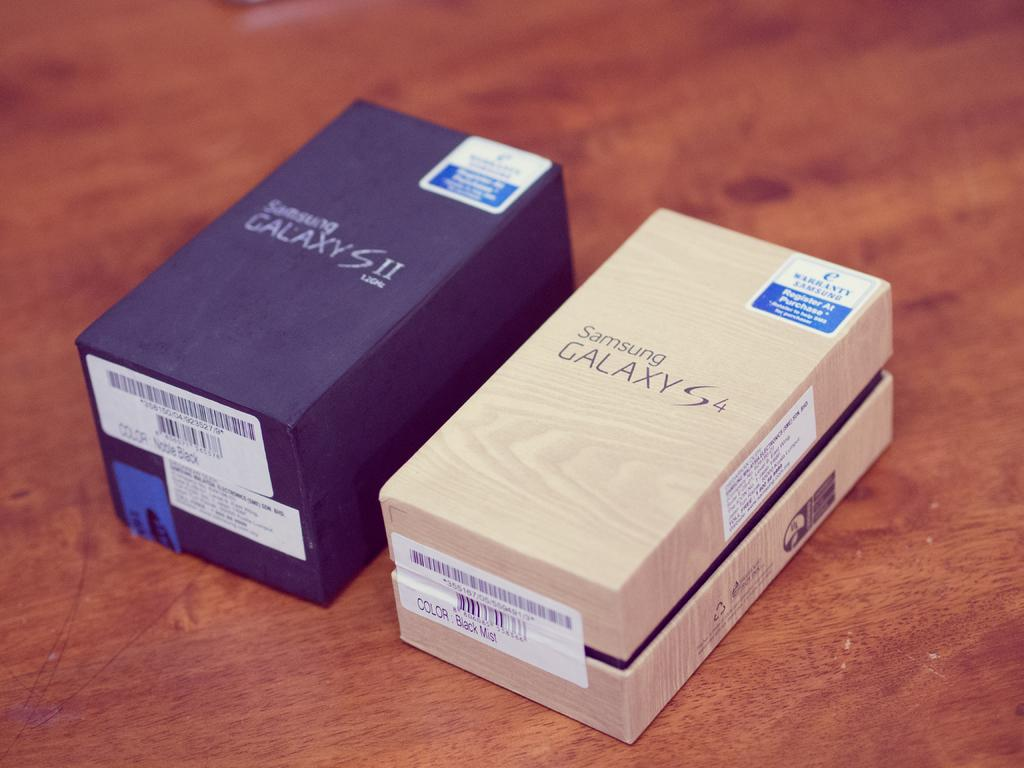Provide a one-sentence caption for the provided image. Two galaxy phones in a box one is a two and other one is four. 